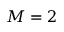Convert formula to latex. <formula><loc_0><loc_0><loc_500><loc_500>M = 2</formula> 